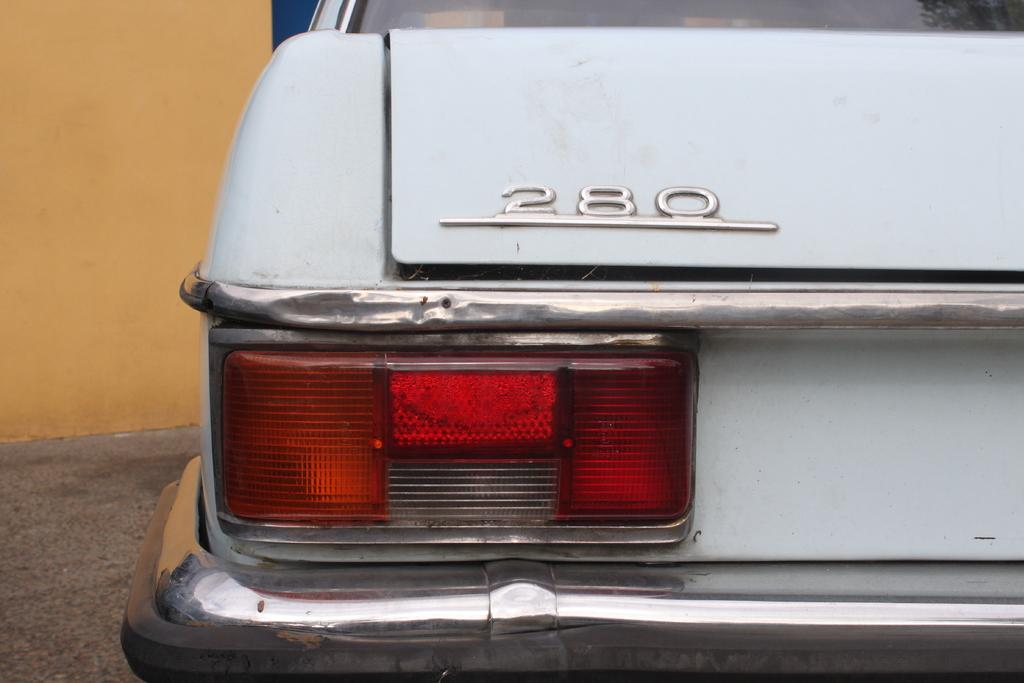What is the main subject of the image? The main subject of the image is a car. Where is the car located in the image? The car is on the road in the image. What is in front of the car? There is a wall in front of the car in the image. How many necks can be seen on the car in the image? There are no necks visible on the car in the image, as cars do not have necks. 